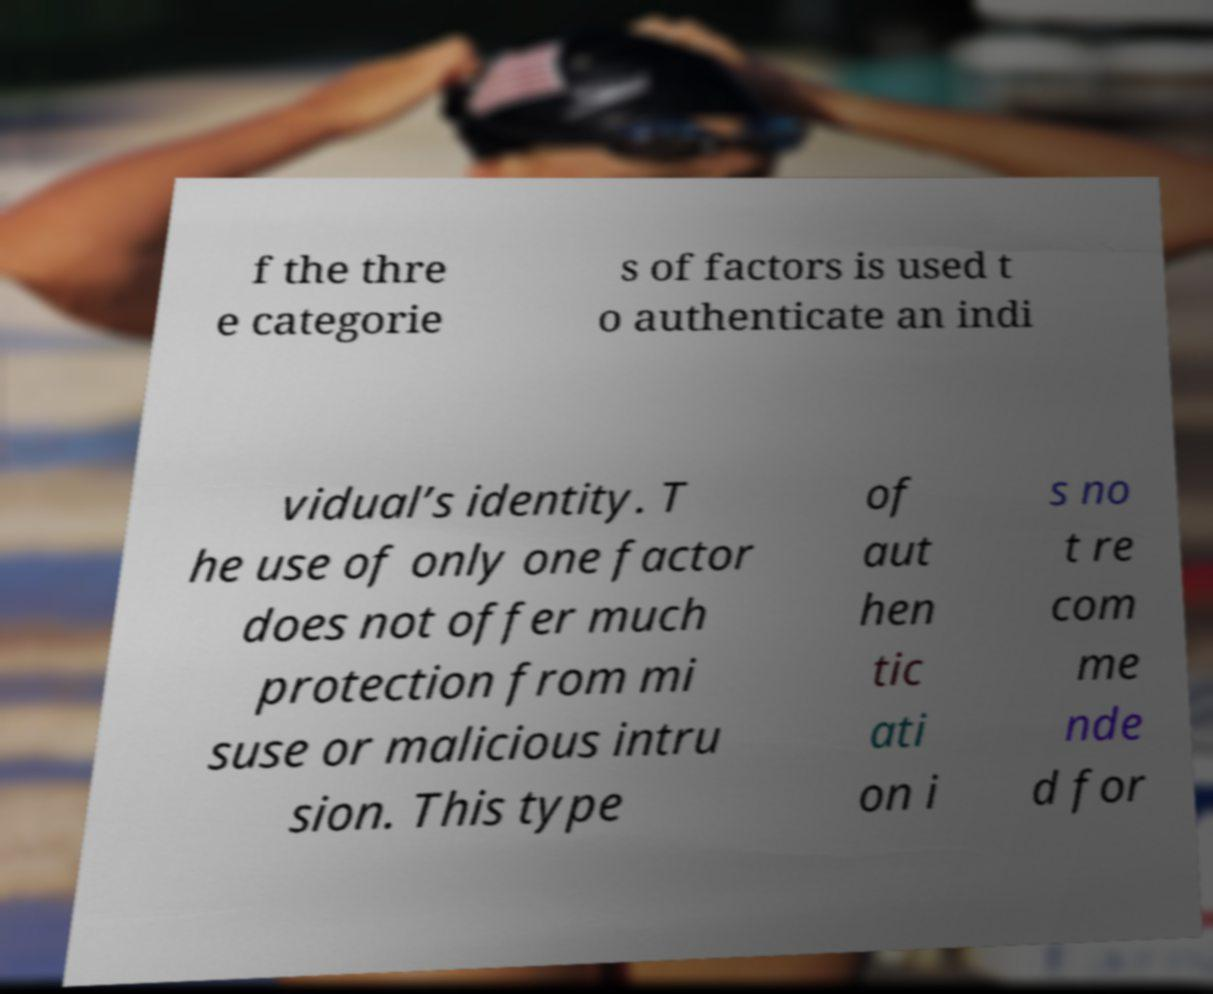Can you accurately transcribe the text from the provided image for me? f the thre e categorie s of factors is used t o authenticate an indi vidual’s identity. T he use of only one factor does not offer much protection from mi suse or malicious intru sion. This type of aut hen tic ati on i s no t re com me nde d for 